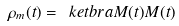<formula> <loc_0><loc_0><loc_500><loc_500>\rho _ { m } ( t ) = \ k e t b r a { M ( t ) } { M ( t ) }</formula> 